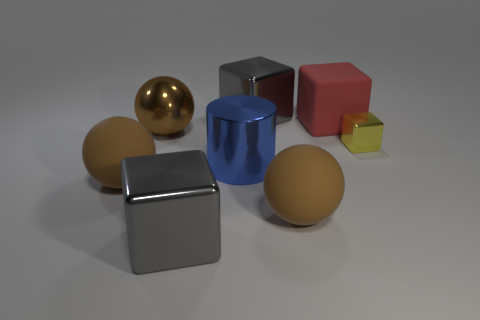Do the brown object on the right side of the big brown metal thing and the brown object to the left of the brown metal sphere have the same shape?
Provide a succinct answer. Yes. Is the size of the red block the same as the brown shiny object behind the big blue shiny cylinder?
Offer a terse response. Yes. Are there more large blocks than red rubber blocks?
Offer a terse response. Yes. Is the large gray thing that is behind the cylinder made of the same material as the big gray block that is in front of the tiny block?
Provide a succinct answer. Yes. What is the material of the small thing?
Ensure brevity in your answer.  Metal. Is the number of big blue things that are behind the small yellow object greater than the number of yellow things?
Provide a succinct answer. No. There is a large gray object that is behind the large red thing behind the yellow metal thing; how many gray blocks are behind it?
Make the answer very short. 0. What material is the cube that is both to the left of the tiny thing and in front of the big red thing?
Keep it short and to the point. Metal. The small block has what color?
Offer a very short reply. Yellow. Is the number of tiny yellow things that are behind the big metallic sphere greater than the number of metallic balls that are left of the big blue metal thing?
Your answer should be very brief. No. 